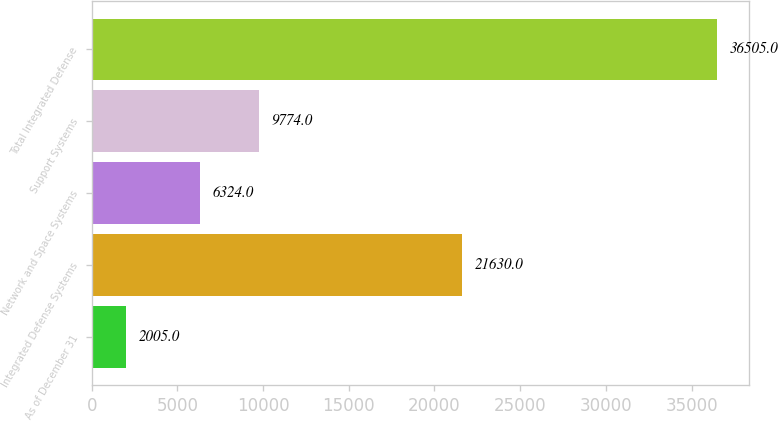<chart> <loc_0><loc_0><loc_500><loc_500><bar_chart><fcel>As of December 31<fcel>Integrated Defense Systems<fcel>Network and Space Systems<fcel>Support Systems<fcel>Total Integrated Defense<nl><fcel>2005<fcel>21630<fcel>6324<fcel>9774<fcel>36505<nl></chart> 